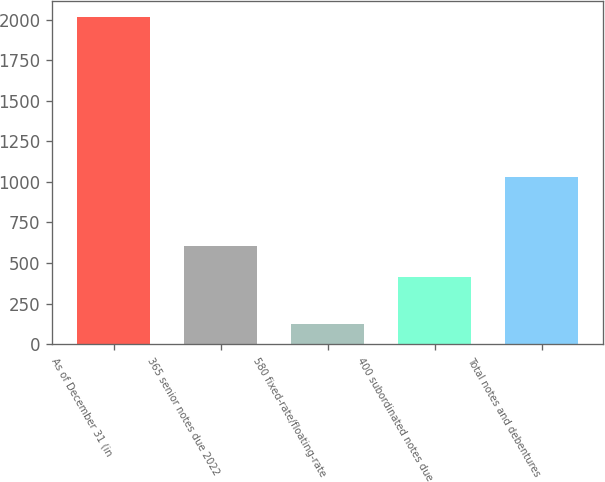Convert chart to OTSL. <chart><loc_0><loc_0><loc_500><loc_500><bar_chart><fcel>As of December 31 (in<fcel>365 senior notes due 2022<fcel>580 fixed-rate/floating-rate<fcel>400 subordinated notes due<fcel>Total notes and debentures<nl><fcel>2015<fcel>602.53<fcel>123.7<fcel>413.4<fcel>1033.1<nl></chart> 